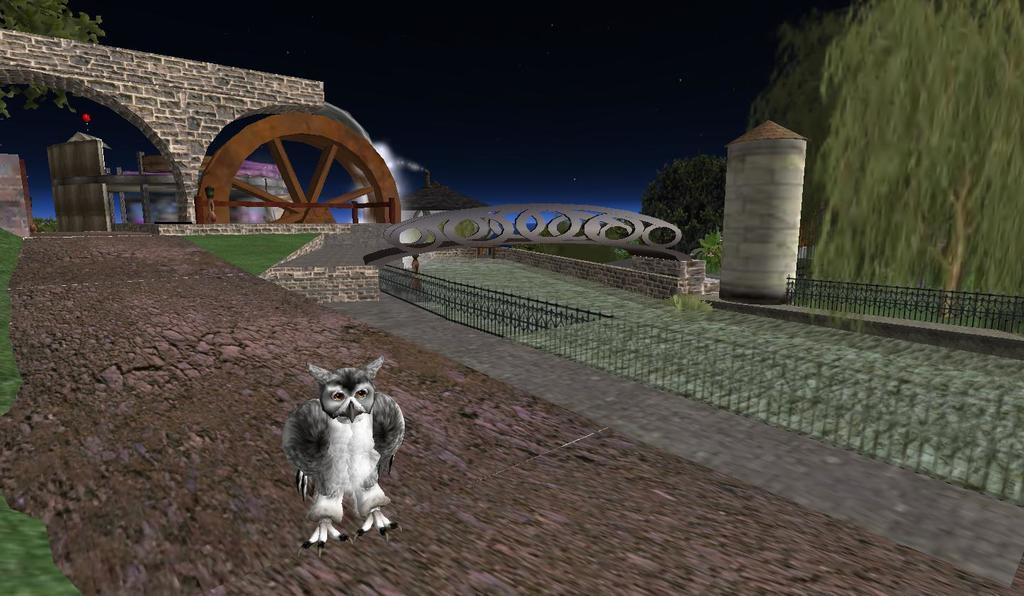Describe this image in one or two sentences. This picture is an edited image, in the picture I can see an animal and fence and trees on the right side, at the top there is the sky and entrance wall and wheel visible in the middle, on the left side I can see a tree 